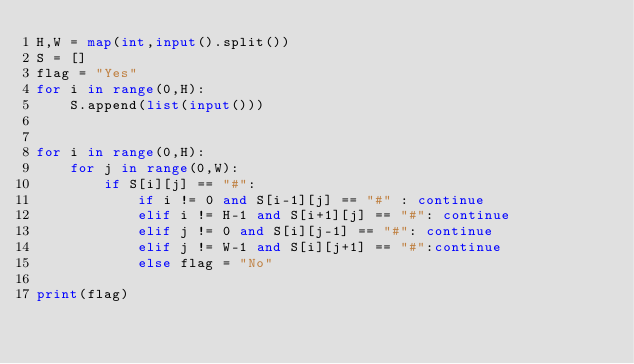Convert code to text. <code><loc_0><loc_0><loc_500><loc_500><_Python_>H,W = map(int,input().split())
S = []
flag = "Yes"
for i in range(0,H):
    S.append(list(input()))

    
for i in range(0,H):
    for j in range(0,W):
        if S[i][j] == "#":
            if i != 0 and S[i-1][j] == "#" : continue
            elif i != H-1 and S[i+1][j] == "#": continue
            elif j != 0 and S[i][j-1] == "#": continue
            elif j != W-1 and S[i][j+1] == "#":continue
            else flag = "No"
            
print(flag)
          </code> 